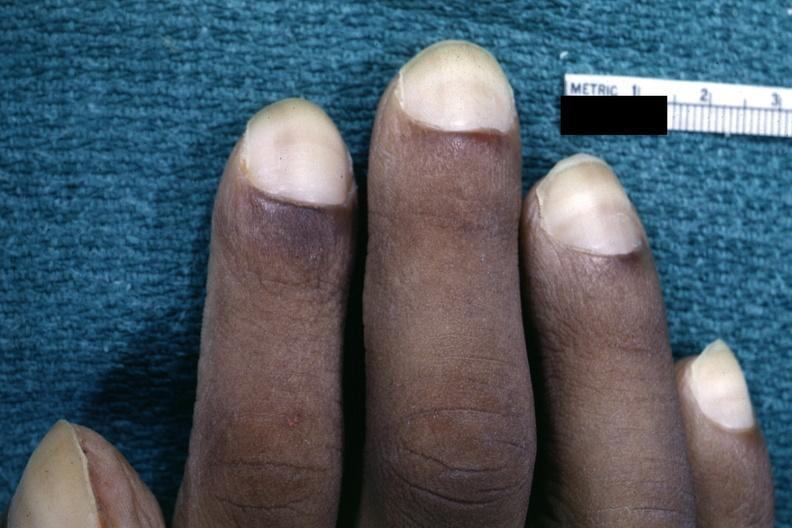does lymphangiomatosis show close-up view of pulmonary osteoarthropathy?
Answer the question using a single word or phrase. No 